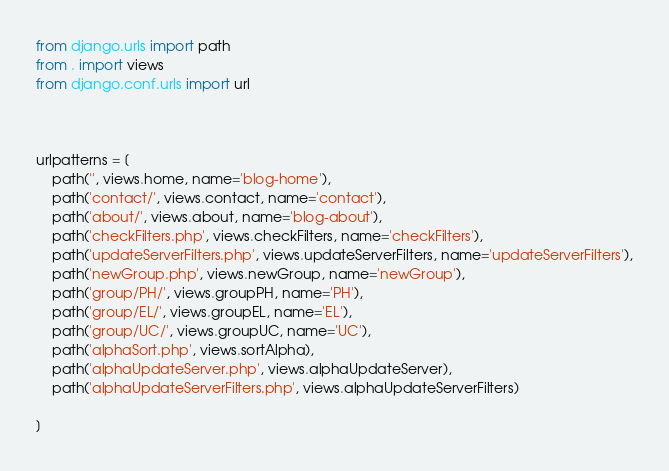<code> <loc_0><loc_0><loc_500><loc_500><_Python_>from django.urls import path
from . import views
from django.conf.urls import url



urlpatterns = [
    path('', views.home, name='blog-home'),
    path('contact/', views.contact, name='contact'),
    path('about/', views.about, name='blog-about'),
    path('checkFilters.php', views.checkFilters, name='checkFilters'),
    path('updateServerFilters.php', views.updateServerFilters, name='updateServerFilters'),
    path('newGroup.php', views.newGroup, name='newGroup'),
    path('group/PH/', views.groupPH, name='PH'),
    path('group/EL/', views.groupEL, name='EL'),
    path('group/UC/', views.groupUC, name='UC'),
    path('alphaSort.php', views.sortAlpha),
    path('alphaUpdateServer.php', views.alphaUpdateServer),
    path('alphaUpdateServerFilters.php', views.alphaUpdateServerFilters)

]

</code> 